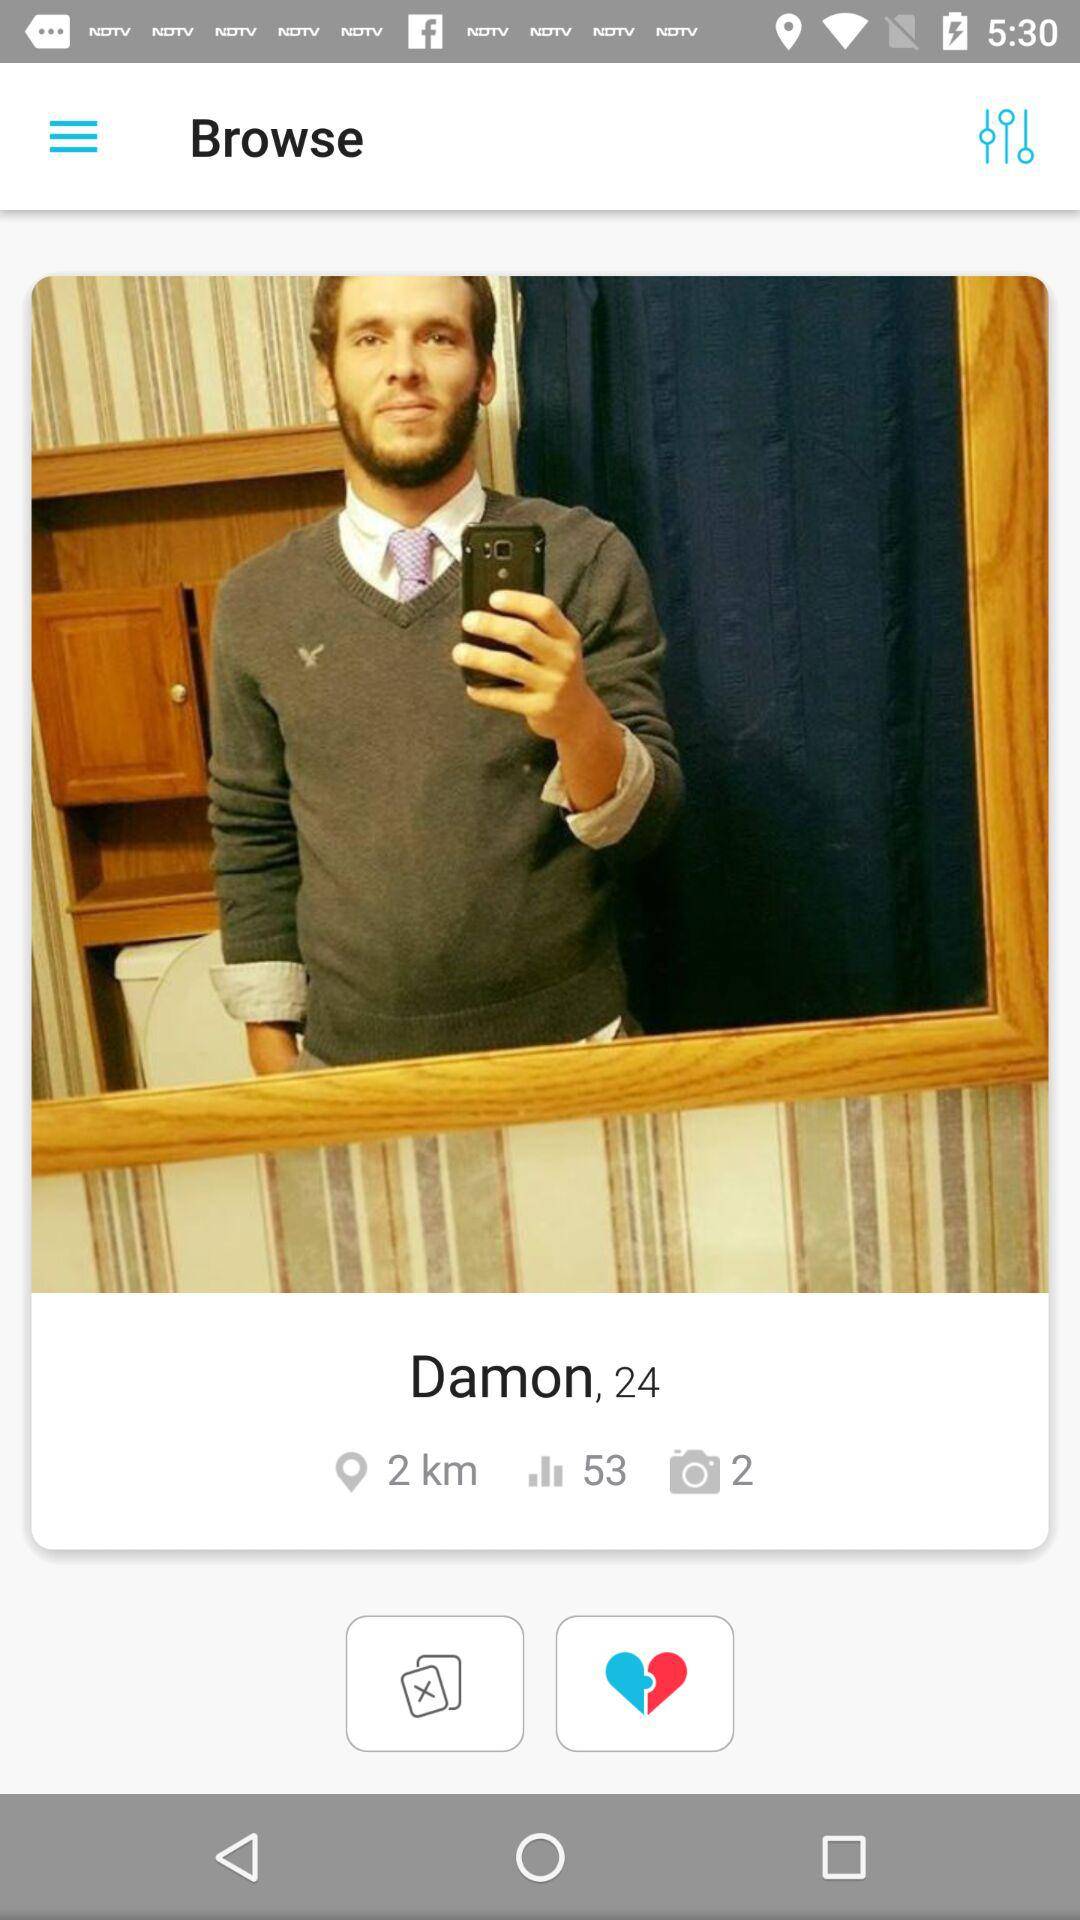How many kilometers are given? There are 2 kilometers given. 